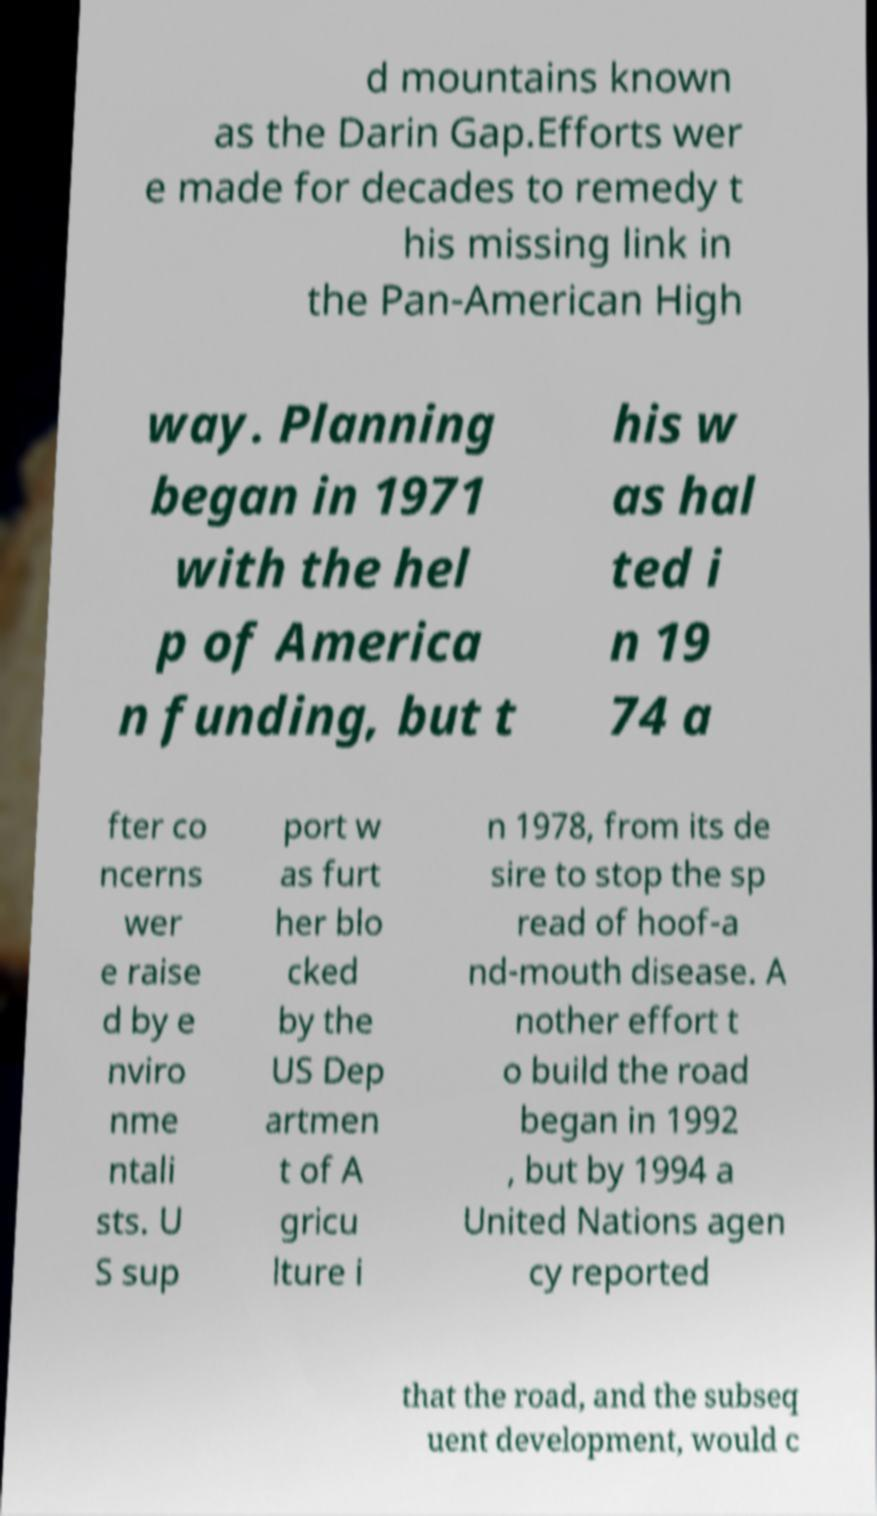Could you extract and type out the text from this image? d mountains known as the Darin Gap.Efforts wer e made for decades to remedy t his missing link in the Pan-American High way. Planning began in 1971 with the hel p of America n funding, but t his w as hal ted i n 19 74 a fter co ncerns wer e raise d by e nviro nme ntali sts. U S sup port w as furt her blo cked by the US Dep artmen t of A gricu lture i n 1978, from its de sire to stop the sp read of hoof-a nd-mouth disease. A nother effort t o build the road began in 1992 , but by 1994 a United Nations agen cy reported that the road, and the subseq uent development, would c 